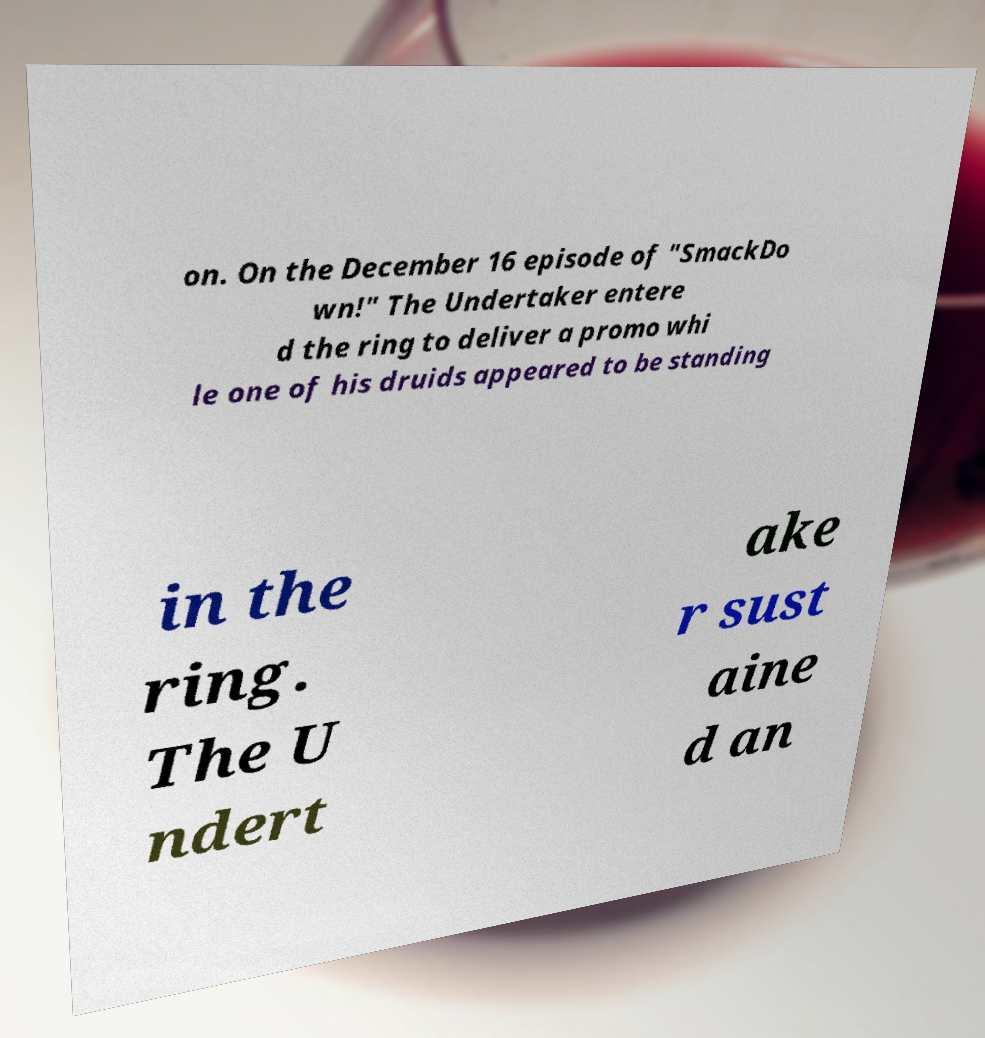Please identify and transcribe the text found in this image. on. On the December 16 episode of "SmackDo wn!" The Undertaker entere d the ring to deliver a promo whi le one of his druids appeared to be standing in the ring. The U ndert ake r sust aine d an 